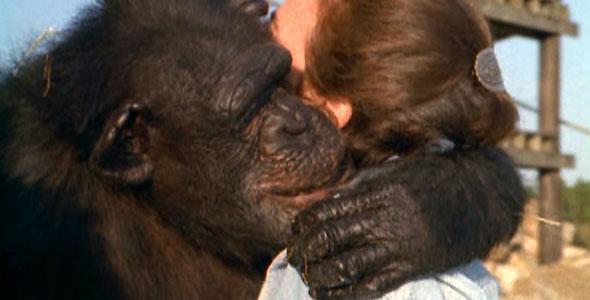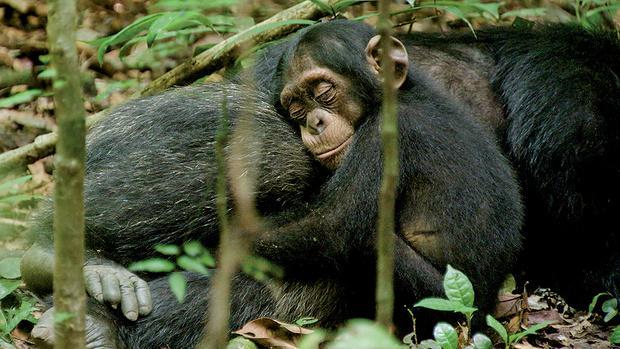The first image is the image on the left, the second image is the image on the right. For the images displayed, is the sentence "In one of the images a baby monkey is cuddling its mother." factually correct? Answer yes or no. Yes. 